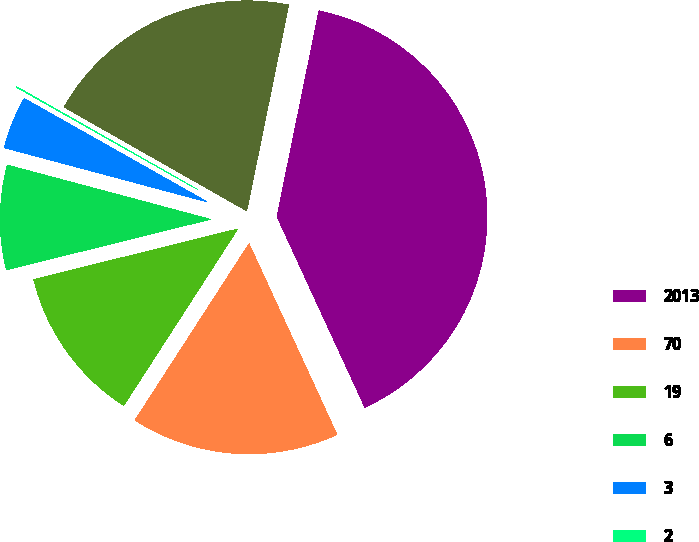<chart> <loc_0><loc_0><loc_500><loc_500><pie_chart><fcel>2013<fcel>70<fcel>19<fcel>6<fcel>3<fcel>2<fcel>100<nl><fcel>39.93%<fcel>16.0%<fcel>12.01%<fcel>8.02%<fcel>4.03%<fcel>0.04%<fcel>19.98%<nl></chart> 